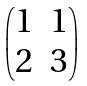<formula> <loc_0><loc_0><loc_500><loc_500>\begin{pmatrix} 1 & 1 \\ 2 & 3 \end{pmatrix}</formula> 